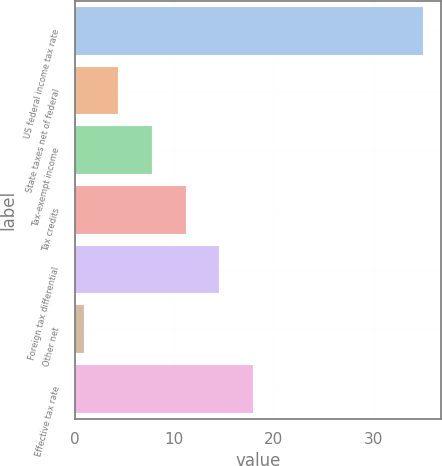Convert chart. <chart><loc_0><loc_0><loc_500><loc_500><bar_chart><fcel>US federal income tax rate<fcel>State taxes net of federal<fcel>Tax-exempt income<fcel>Tax credits<fcel>Foreign tax differential<fcel>Other net<fcel>Effective tax rate<nl><fcel>35<fcel>4.31<fcel>7.72<fcel>11.13<fcel>14.54<fcel>0.9<fcel>17.95<nl></chart> 